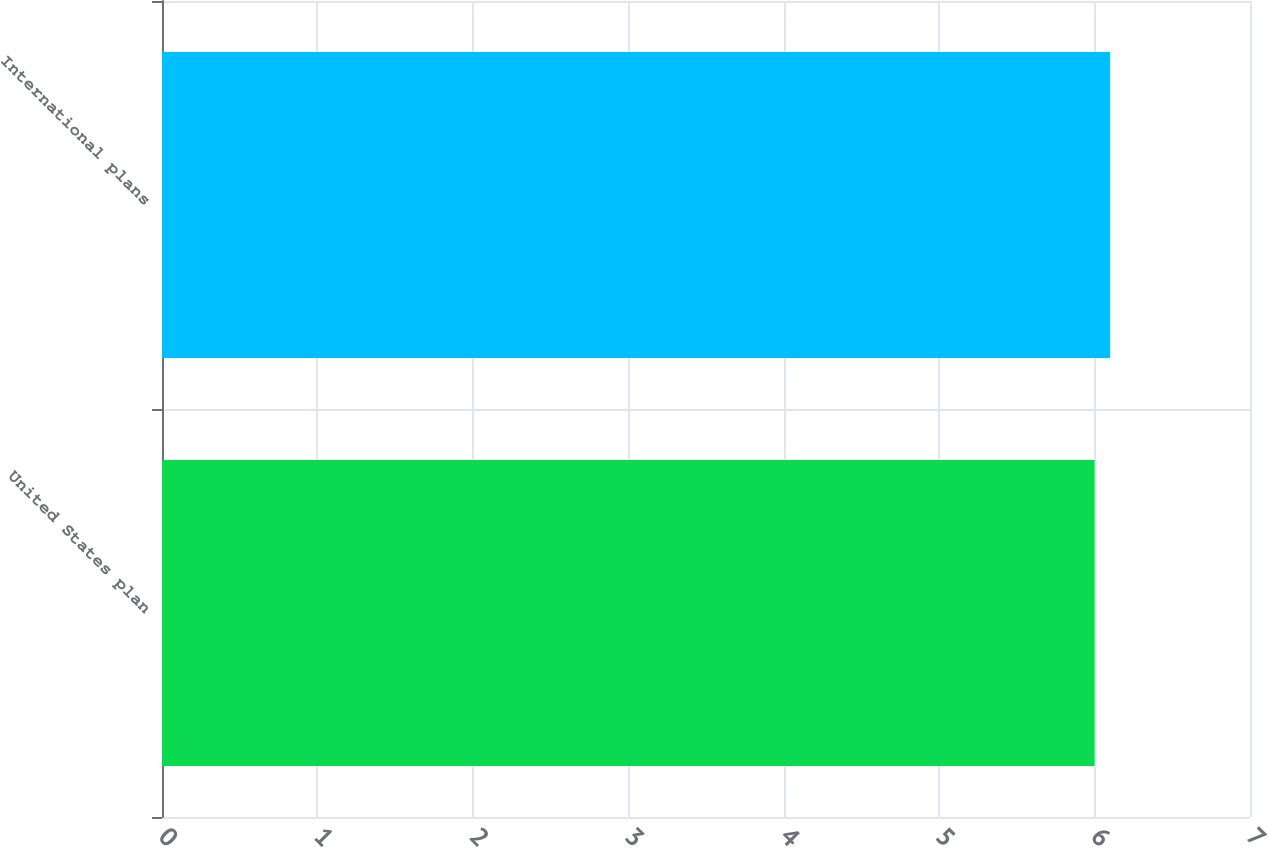Convert chart to OTSL. <chart><loc_0><loc_0><loc_500><loc_500><bar_chart><fcel>United States plan<fcel>International plans<nl><fcel>6<fcel>6.1<nl></chart> 